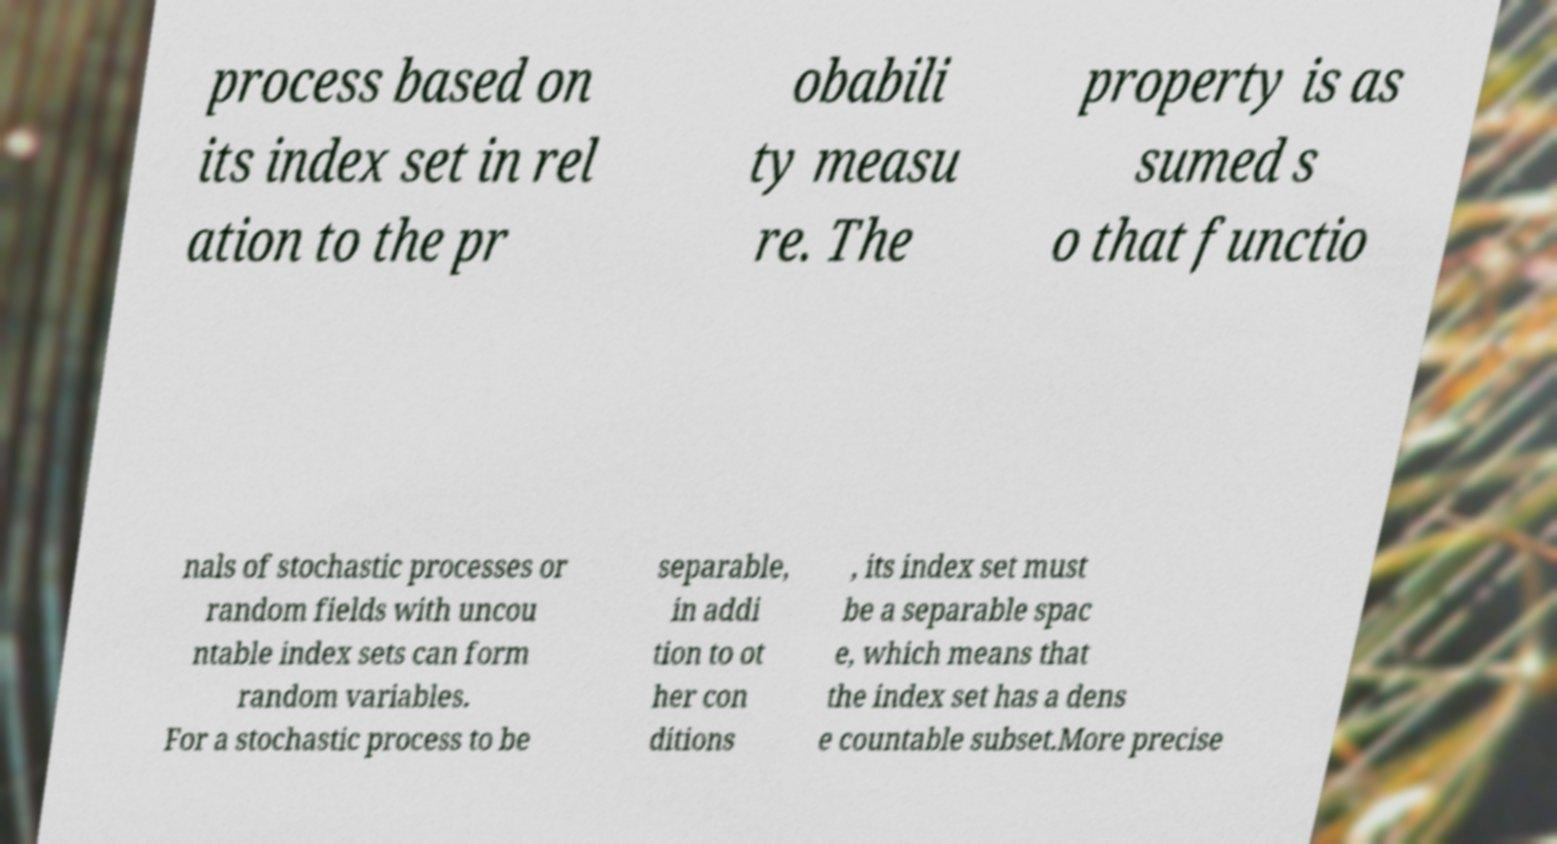What messages or text are displayed in this image? I need them in a readable, typed format. process based on its index set in rel ation to the pr obabili ty measu re. The property is as sumed s o that functio nals of stochastic processes or random fields with uncou ntable index sets can form random variables. For a stochastic process to be separable, in addi tion to ot her con ditions , its index set must be a separable spac e, which means that the index set has a dens e countable subset.More precise 